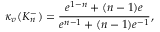<formula> <loc_0><loc_0><loc_500><loc_500>\kappa _ { v } ( K _ { n } ^ { - } ) = \frac { { e ^ { 1 - n } } + ( n - 1 ) e } { { e ^ { n - 1 } } + ( n - 1 ) e ^ { - 1 } } ,</formula> 